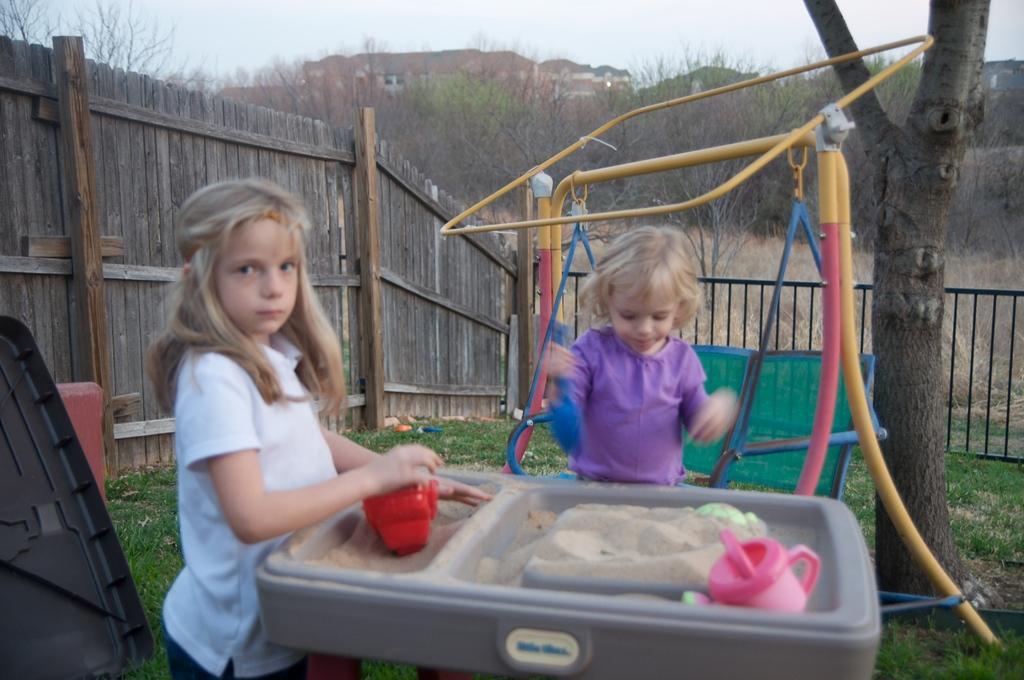Could you give a brief overview of what you see in this image? In this picture there are kids and we can see grass, black object, sand and toys in a container. We can see swing with stand, tree and fences. In the background of the image we can see trees, houses, grass and sky. 